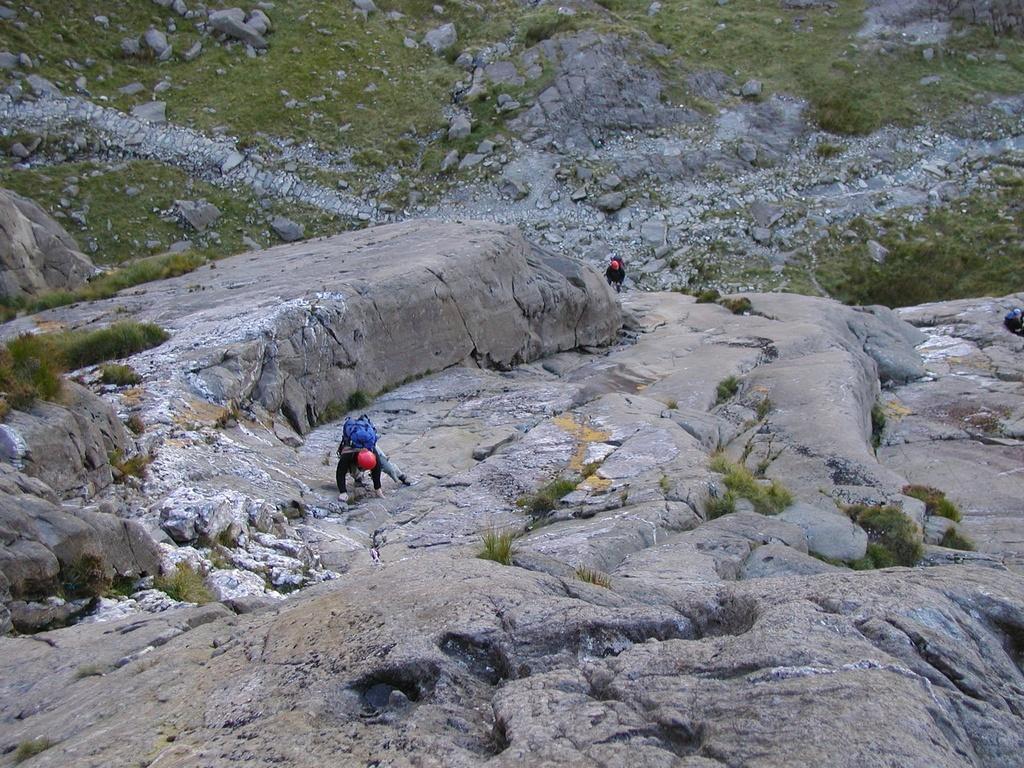Can you describe this image briefly? In this image we can see the people climbing the hill. We can also see the rocks and also the grass. 